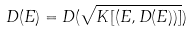Convert formula to latex. <formula><loc_0><loc_0><loc_500><loc_500>D ( E ) = D ( \sqrt { K [ ( E , D ( E ) ) ] } )</formula> 